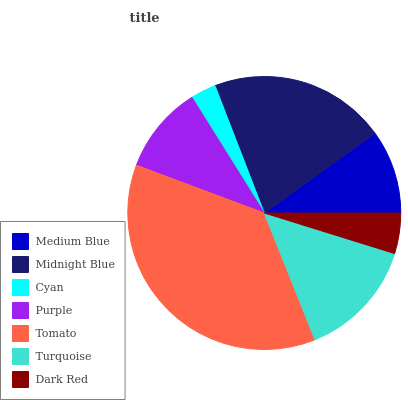Is Cyan the minimum?
Answer yes or no. Yes. Is Tomato the maximum?
Answer yes or no. Yes. Is Midnight Blue the minimum?
Answer yes or no. No. Is Midnight Blue the maximum?
Answer yes or no. No. Is Midnight Blue greater than Medium Blue?
Answer yes or no. Yes. Is Medium Blue less than Midnight Blue?
Answer yes or no. Yes. Is Medium Blue greater than Midnight Blue?
Answer yes or no. No. Is Midnight Blue less than Medium Blue?
Answer yes or no. No. Is Purple the high median?
Answer yes or no. Yes. Is Purple the low median?
Answer yes or no. Yes. Is Turquoise the high median?
Answer yes or no. No. Is Dark Red the low median?
Answer yes or no. No. 